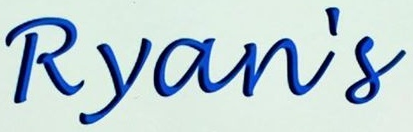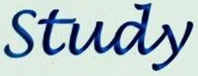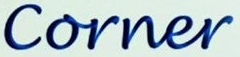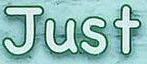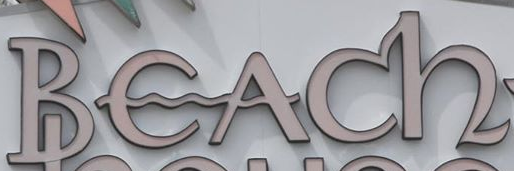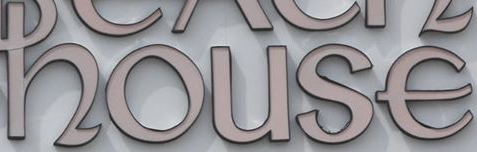What text is displayed in these images sequentially, separated by a semicolon? Ryan's; Study; Corner; Just; Beach; house 